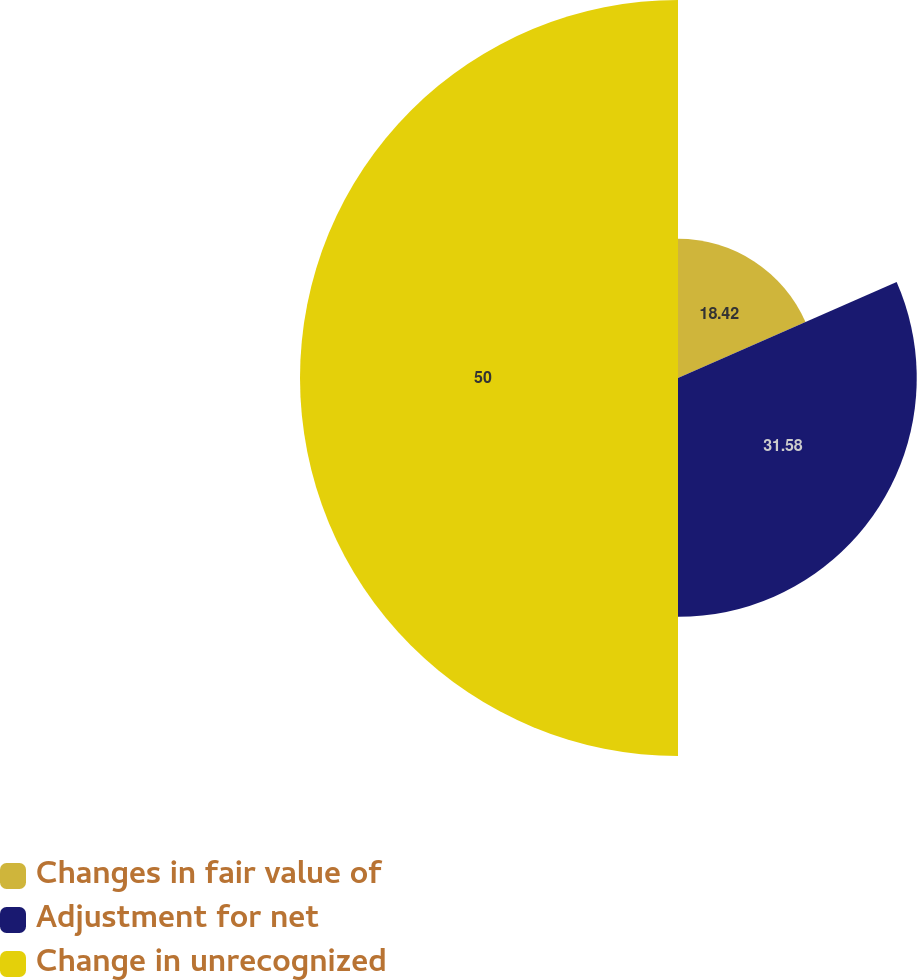Convert chart. <chart><loc_0><loc_0><loc_500><loc_500><pie_chart><fcel>Changes in fair value of<fcel>Adjustment for net<fcel>Change in unrecognized<nl><fcel>18.42%<fcel>31.58%<fcel>50.0%<nl></chart> 